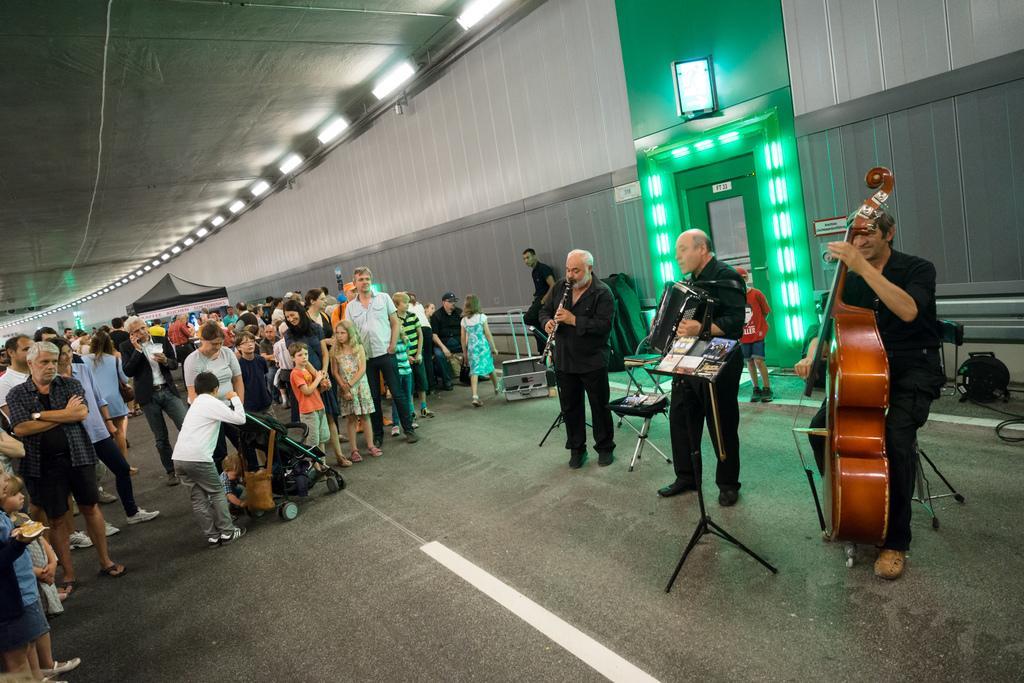Can you describe this image briefly? In this image there are some persons standing at left side of this image and there are three persons at right side of this image is playing instruments , this person is wearing black color dress and holding a guitar and there is a door at right side of the image ,and there is a wall in the background. there are some lights arranged at top of this image. There is a baby trolley at bottom of this image. 